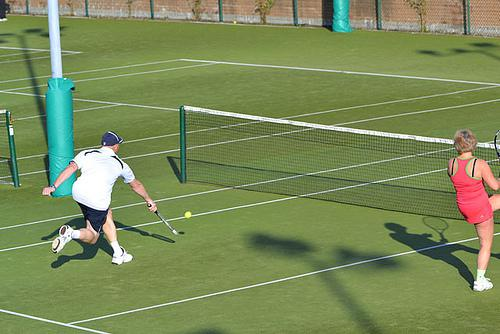Question: where is this scene?
Choices:
A. Beach.
B. Ice rink.
C. Tennis court.
D. Skate park.
Answer with the letter. Answer: C Question: what color is the court?
Choices:
A. White.
B. Green.
C. Black.
D. Blue.
Answer with the letter. Answer: B Question: what is cast?
Choices:
A. Dye.
B. An arm.
C. Shadow.
D. A play.
Answer with the letter. Answer: C Question: when was this?
Choices:
A. After Winter.
B. July.
C. Daytime.
D. Dusk.
Answer with the letter. Answer: C 